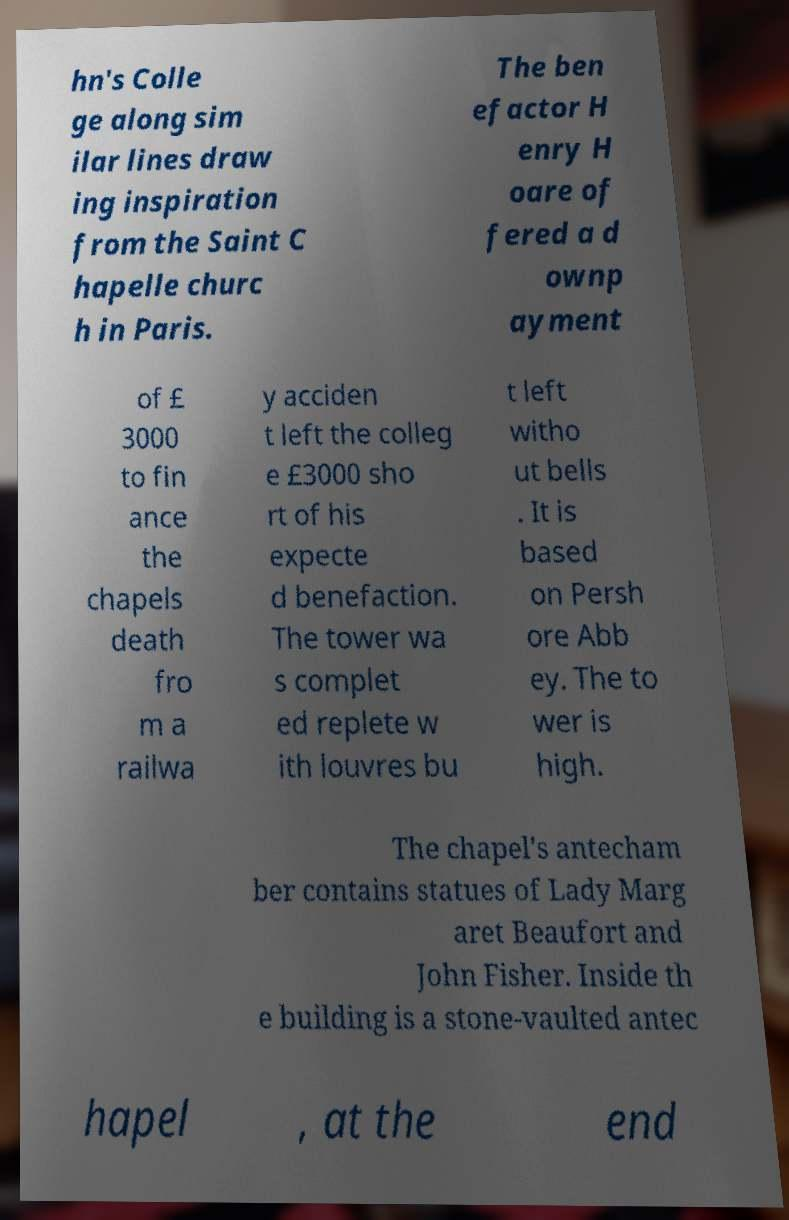For documentation purposes, I need the text within this image transcribed. Could you provide that? hn's Colle ge along sim ilar lines draw ing inspiration from the Saint C hapelle churc h in Paris. The ben efactor H enry H oare of fered a d ownp ayment of £ 3000 to fin ance the chapels death fro m a railwa y acciden t left the colleg e £3000 sho rt of his expecte d benefaction. The tower wa s complet ed replete w ith louvres bu t left witho ut bells . It is based on Persh ore Abb ey. The to wer is high. The chapel's antecham ber contains statues of Lady Marg aret Beaufort and John Fisher. Inside th e building is a stone-vaulted antec hapel , at the end 